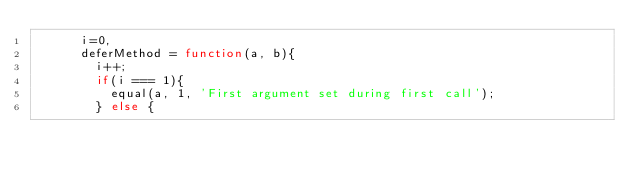Convert code to text. <code><loc_0><loc_0><loc_500><loc_500><_JavaScript_>      i=0,
      deferMethod = function(a, b){
        i++;
        if(i === 1){
          equal(a, 1, 'First argument set during first call');
        } else {</code> 